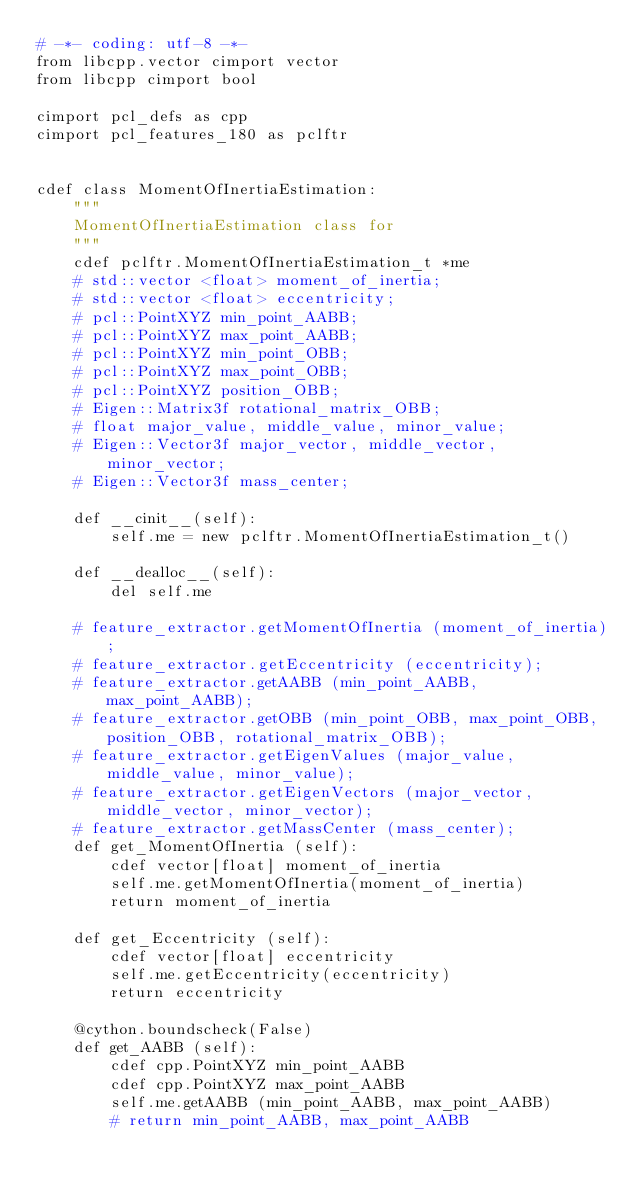<code> <loc_0><loc_0><loc_500><loc_500><_Cython_># -*- coding: utf-8 -*-
from libcpp.vector cimport vector
from libcpp cimport bool

cimport pcl_defs as cpp
cimport pcl_features_180 as pclftr


cdef class MomentOfInertiaEstimation:
    """
    MomentOfInertiaEstimation class for 
    """
    cdef pclftr.MomentOfInertiaEstimation_t *me
    # std::vector <float> moment_of_inertia;
    # std::vector <float> eccentricity;
    # pcl::PointXYZ min_point_AABB;
    # pcl::PointXYZ max_point_AABB;
    # pcl::PointXYZ min_point_OBB;
    # pcl::PointXYZ max_point_OBB;
    # pcl::PointXYZ position_OBB;
    # Eigen::Matrix3f rotational_matrix_OBB;
    # float major_value, middle_value, minor_value;
    # Eigen::Vector3f major_vector, middle_vector, minor_vector;
    # Eigen::Vector3f mass_center;

    def __cinit__(self):
        self.me = new pclftr.MomentOfInertiaEstimation_t()

    def __dealloc__(self):
        del self.me

    # feature_extractor.getMomentOfInertia (moment_of_inertia);
    # feature_extractor.getEccentricity (eccentricity);
    # feature_extractor.getAABB (min_point_AABB, max_point_AABB);
    # feature_extractor.getOBB (min_point_OBB, max_point_OBB, position_OBB, rotational_matrix_OBB);
    # feature_extractor.getEigenValues (major_value, middle_value, minor_value);
    # feature_extractor.getEigenVectors (major_vector, middle_vector, minor_vector);
    # feature_extractor.getMassCenter (mass_center);
    def get_MomentOfInertia (self):
        cdef vector[float] moment_of_inertia
        self.me.getMomentOfInertia(moment_of_inertia)
        return moment_of_inertia

    def get_Eccentricity (self):
        cdef vector[float] eccentricity
        self.me.getEccentricity(eccentricity)
        return eccentricity

    @cython.boundscheck(False)
    def get_AABB (self):
        cdef cpp.PointXYZ min_point_AABB
        cdef cpp.PointXYZ max_point_AABB
        self.me.getAABB (min_point_AABB, max_point_AABB)
        # return min_point_AABB, max_point_AABB
        </code> 